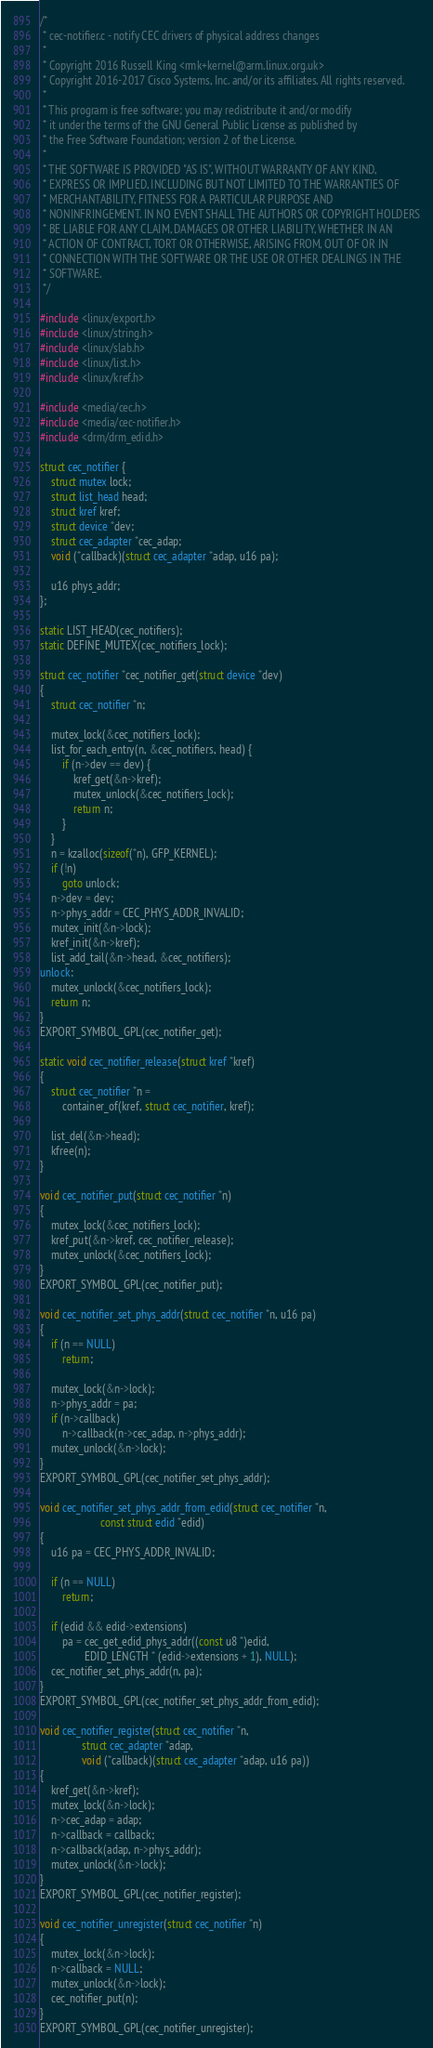Convert code to text. <code><loc_0><loc_0><loc_500><loc_500><_C_>/*
 * cec-notifier.c - notify CEC drivers of physical address changes
 *
 * Copyright 2016 Russell King <rmk+kernel@arm.linux.org.uk>
 * Copyright 2016-2017 Cisco Systems, Inc. and/or its affiliates. All rights reserved.
 *
 * This program is free software; you may redistribute it and/or modify
 * it under the terms of the GNU General Public License as published by
 * the Free Software Foundation; version 2 of the License.
 *
 * THE SOFTWARE IS PROVIDED "AS IS", WITHOUT WARRANTY OF ANY KIND,
 * EXPRESS OR IMPLIED, INCLUDING BUT NOT LIMITED TO THE WARRANTIES OF
 * MERCHANTABILITY, FITNESS FOR A PARTICULAR PURPOSE AND
 * NONINFRINGEMENT. IN NO EVENT SHALL THE AUTHORS OR COPYRIGHT HOLDERS
 * BE LIABLE FOR ANY CLAIM, DAMAGES OR OTHER LIABILITY, WHETHER IN AN
 * ACTION OF CONTRACT, TORT OR OTHERWISE, ARISING FROM, OUT OF OR IN
 * CONNECTION WITH THE SOFTWARE OR THE USE OR OTHER DEALINGS IN THE
 * SOFTWARE.
 */

#include <linux/export.h>
#include <linux/string.h>
#include <linux/slab.h>
#include <linux/list.h>
#include <linux/kref.h>

#include <media/cec.h>
#include <media/cec-notifier.h>
#include <drm/drm_edid.h>

struct cec_notifier {
	struct mutex lock;
	struct list_head head;
	struct kref kref;
	struct device *dev;
	struct cec_adapter *cec_adap;
	void (*callback)(struct cec_adapter *adap, u16 pa);

	u16 phys_addr;
};

static LIST_HEAD(cec_notifiers);
static DEFINE_MUTEX(cec_notifiers_lock);

struct cec_notifier *cec_notifier_get(struct device *dev)
{
	struct cec_notifier *n;

	mutex_lock(&cec_notifiers_lock);
	list_for_each_entry(n, &cec_notifiers, head) {
		if (n->dev == dev) {
			kref_get(&n->kref);
			mutex_unlock(&cec_notifiers_lock);
			return n;
		}
	}
	n = kzalloc(sizeof(*n), GFP_KERNEL);
	if (!n)
		goto unlock;
	n->dev = dev;
	n->phys_addr = CEC_PHYS_ADDR_INVALID;
	mutex_init(&n->lock);
	kref_init(&n->kref);
	list_add_tail(&n->head, &cec_notifiers);
unlock:
	mutex_unlock(&cec_notifiers_lock);
	return n;
}
EXPORT_SYMBOL_GPL(cec_notifier_get);

static void cec_notifier_release(struct kref *kref)
{
	struct cec_notifier *n =
		container_of(kref, struct cec_notifier, kref);

	list_del(&n->head);
	kfree(n);
}

void cec_notifier_put(struct cec_notifier *n)
{
	mutex_lock(&cec_notifiers_lock);
	kref_put(&n->kref, cec_notifier_release);
	mutex_unlock(&cec_notifiers_lock);
}
EXPORT_SYMBOL_GPL(cec_notifier_put);

void cec_notifier_set_phys_addr(struct cec_notifier *n, u16 pa)
{
	if (n == NULL)
		return;

	mutex_lock(&n->lock);
	n->phys_addr = pa;
	if (n->callback)
		n->callback(n->cec_adap, n->phys_addr);
	mutex_unlock(&n->lock);
}
EXPORT_SYMBOL_GPL(cec_notifier_set_phys_addr);

void cec_notifier_set_phys_addr_from_edid(struct cec_notifier *n,
					  const struct edid *edid)
{
	u16 pa = CEC_PHYS_ADDR_INVALID;

	if (n == NULL)
		return;

	if (edid && edid->extensions)
		pa = cec_get_edid_phys_addr((const u8 *)edid,
				EDID_LENGTH * (edid->extensions + 1), NULL);
	cec_notifier_set_phys_addr(n, pa);
}
EXPORT_SYMBOL_GPL(cec_notifier_set_phys_addr_from_edid);

void cec_notifier_register(struct cec_notifier *n,
			   struct cec_adapter *adap,
			   void (*callback)(struct cec_adapter *adap, u16 pa))
{
	kref_get(&n->kref);
	mutex_lock(&n->lock);
	n->cec_adap = adap;
	n->callback = callback;
	n->callback(adap, n->phys_addr);
	mutex_unlock(&n->lock);
}
EXPORT_SYMBOL_GPL(cec_notifier_register);

void cec_notifier_unregister(struct cec_notifier *n)
{
	mutex_lock(&n->lock);
	n->callback = NULL;
	mutex_unlock(&n->lock);
	cec_notifier_put(n);
}
EXPORT_SYMBOL_GPL(cec_notifier_unregister);
</code> 